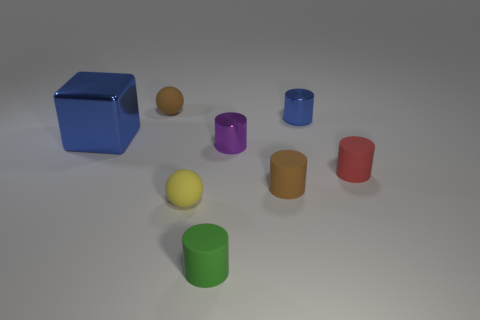Add 1 tiny yellow matte cubes. How many objects exist? 9 Subtract all purple shiny cylinders. How many cylinders are left? 4 Subtract all blocks. How many objects are left? 7 Subtract all brown blocks. Subtract all yellow cylinders. How many blocks are left? 1 Subtract all green cylinders. Subtract all brown cylinders. How many objects are left? 6 Add 3 small brown rubber objects. How many small brown rubber objects are left? 5 Add 2 tiny blue metal cylinders. How many tiny blue metal cylinders exist? 3 Subtract all green cylinders. How many cylinders are left? 4 Subtract 0 gray cylinders. How many objects are left? 8 